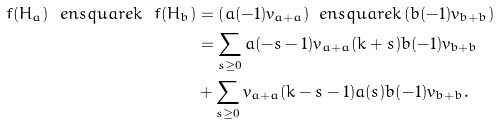<formula> <loc_0><loc_0><loc_500><loc_500>\ f ( H _ { a } ) \ e n s q u a r e k \ f ( H _ { b } ) & = \left ( a ( - 1 ) v _ { a + \bar { a } } \right ) \ e n s q u a r e k \left ( b ( - 1 ) v _ { b + \bar { b } } \right ) \\ & = \sum _ { s \geq 0 } a ( - s - 1 ) v _ { a + \bar { a } } ( k + s ) b ( - 1 ) v _ { b + \bar { b } } \\ & + \sum _ { s \geq 0 } v _ { a + \bar { a } } ( k - s - 1 ) a ( s ) b ( - 1 ) v _ { b + \bar { b } } .</formula> 